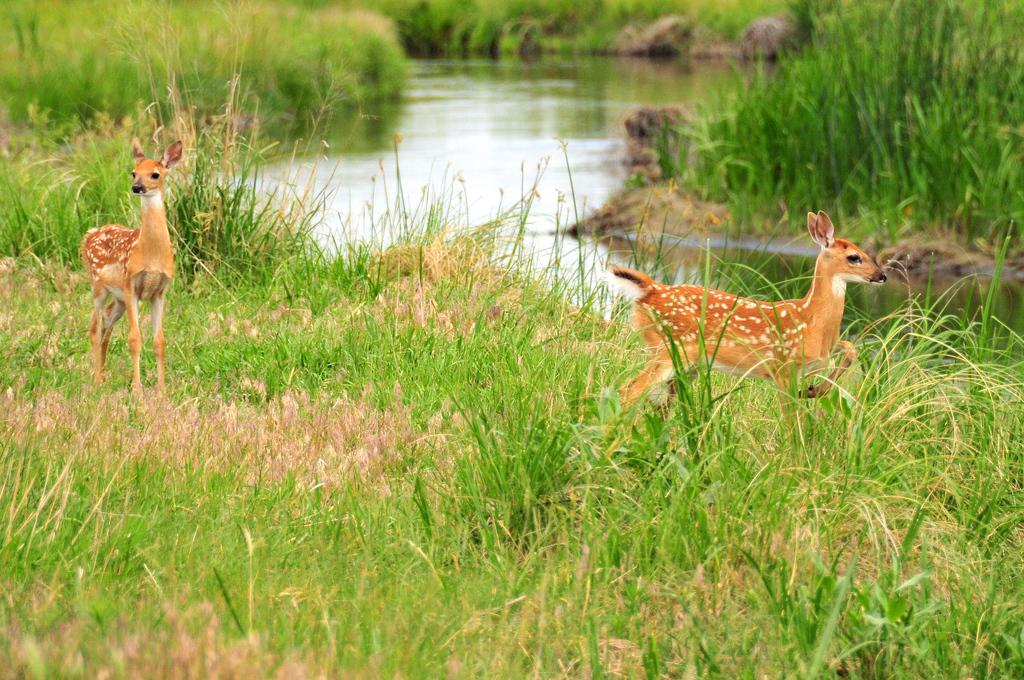What types of living organisms can be seen in the image? There are animals in the image. What type of vegetation is visible at the bottom of the image? There is grass at the bottom of the image. What can be seen in the background of the image? There is water visible in the background of the image. What time of day is it in the image, and what type of cow can be seen grazing in the grass? There is no indication of the time of day in the image, and there is no cow present. 